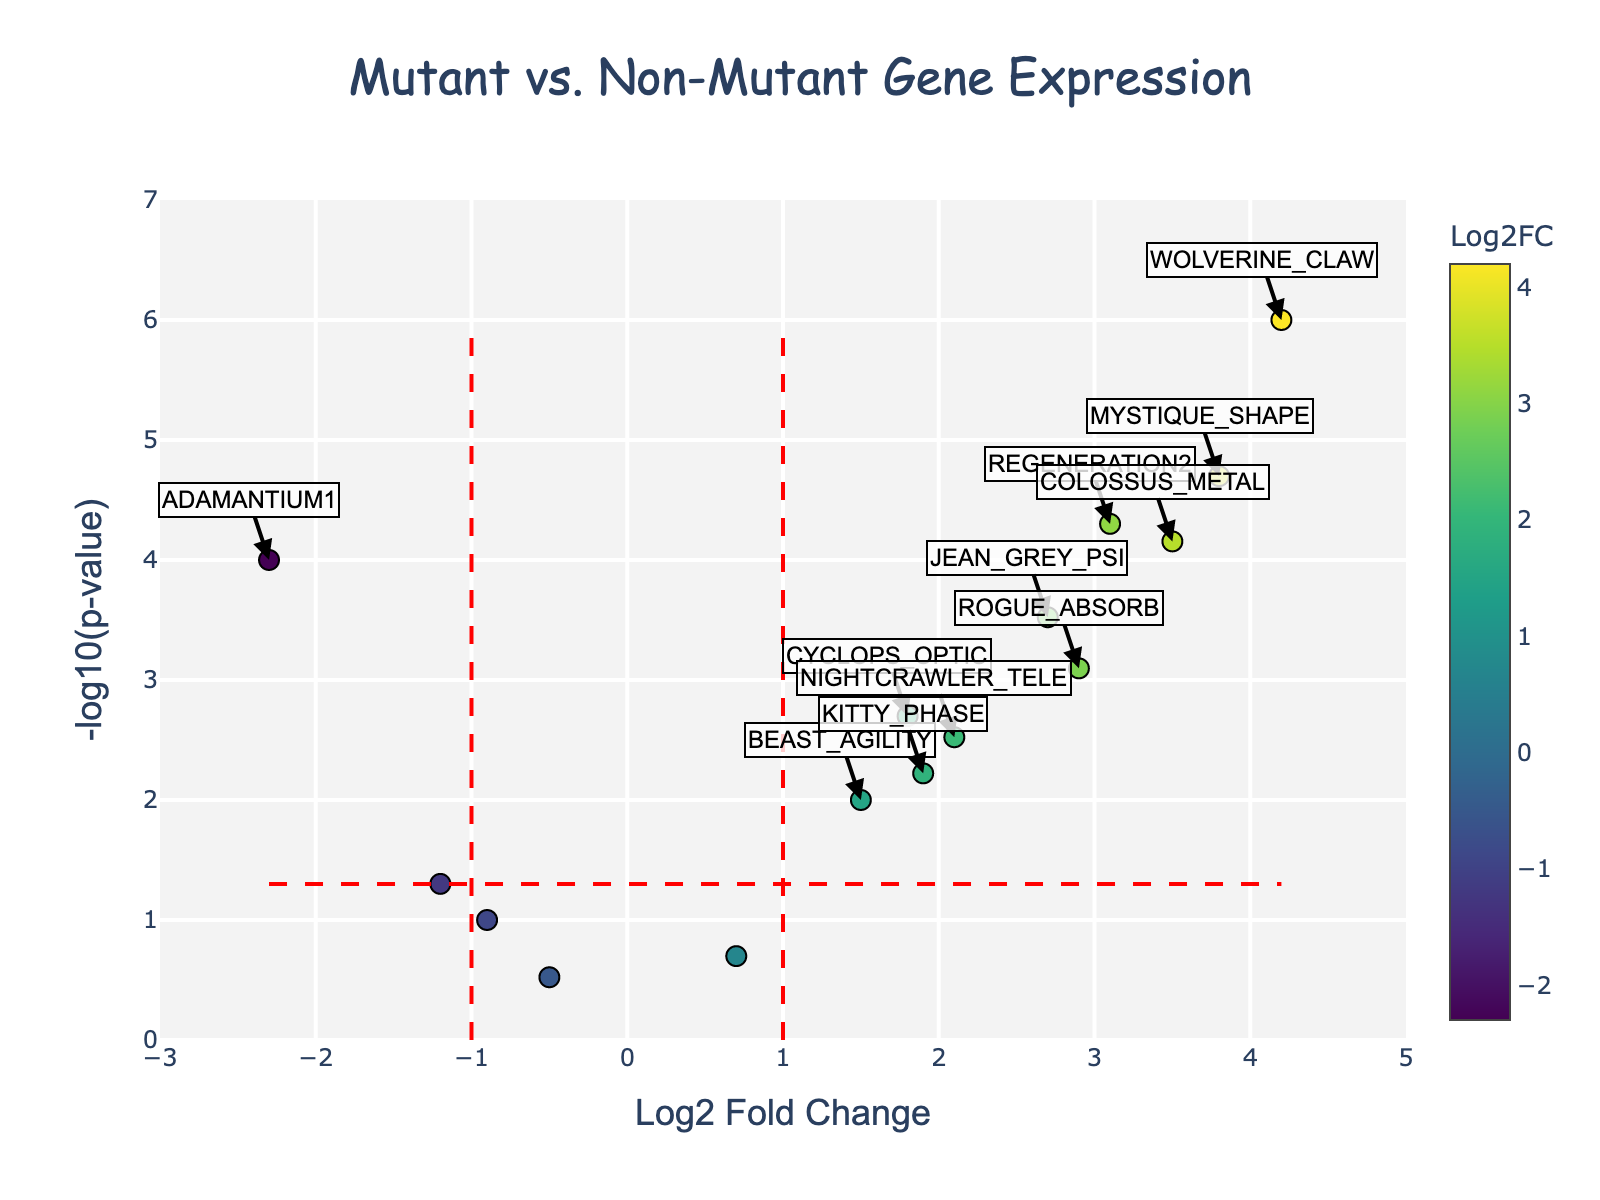Which gene has the highest log2 fold change? To find this, look at the x-axis where the log2 fold change (Log2FC) values are depicted. Identify the point farthest right. Hovering over that point will show the gene name.
Answer: WOLVERINE_CLAW What is the y-axis title and its unit of measurement? The y-axis title is located on the vertical axis of the plot. It is labeled as "-log10(p-value)", and it represents the negative base-10 logarithm of the p-value.
Answer: -log10(p-value) How many genes have a p-value less than 0.05 and an absolute log2 fold change greater than 1? Identify points above the red dashed horizontal line (-log10(p-value) threshold of -log10(0.05)) and outside the vertical red dashed lines (Log2FC thresholds of -1 and 1). Count these points.
Answer: 10 Which genes are annotated as significant in the plot? Significant genes are those annotated with text in the plot. Look at the text annotations placed near the points outside the threshold lines.
Answer: ADAMANTIUM1, REGENERATION2, WOLVERINE_CLAW, JEAN_GREY_PSI, MYSTIQUE_SHAPE, ROGUE_ABSORB, COLOSSUS_METAL, NIGHTCRAWLER_TELE, KITTY_PHASE What is the log2 fold change for the gene JEAN_GREY_PSI? Locate the text annotation for JEAN_GREY_PSI. Check its corresponding position on the x-axis where the log2 fold change values are plotted.
Answer: 2.7 How many data points are plotted in the figure? Each data point represents a gene. Count the total number of plotted points.
Answer: 15 Which gene has the smallest p-value, and what is its corresponding -log10(p-value)? Identify the gene at the highest point in the plot (largest y-value). Hovering over this point reveals the gene name and its -log10(p-value).
Answer: WOLVERINE_CLAW, 6.0 